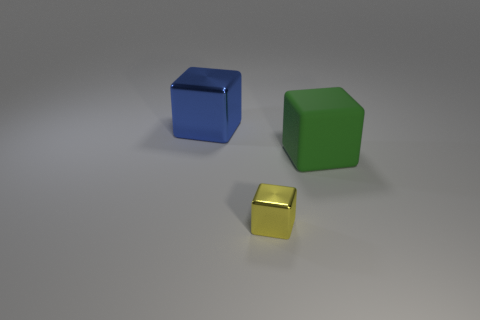Subtract all red blocks. Subtract all gray spheres. How many blocks are left? 3 Add 3 purple metallic cubes. How many objects exist? 6 Add 2 small yellow cubes. How many small yellow cubes exist? 3 Subtract 0 green cylinders. How many objects are left? 3 Subtract all tiny shiny objects. Subtract all yellow things. How many objects are left? 1 Add 3 green rubber blocks. How many green rubber blocks are left? 4 